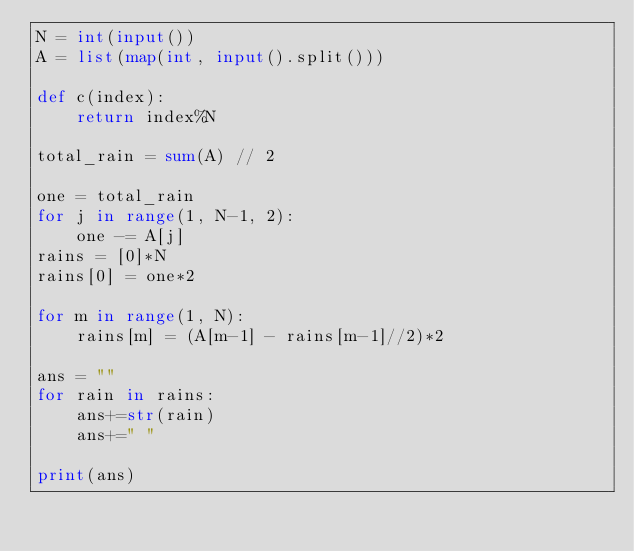Convert code to text. <code><loc_0><loc_0><loc_500><loc_500><_Python_>N = int(input())
A = list(map(int, input().split()))

def c(index):
    return index%N

total_rain = sum(A) // 2

one = total_rain
for j in range(1, N-1, 2):
    one -= A[j]
rains = [0]*N
rains[0] = one*2

for m in range(1, N):
    rains[m] = (A[m-1] - rains[m-1]//2)*2

ans = ""
for rain in rains:
    ans+=str(rain)
    ans+=" "

print(ans)</code> 